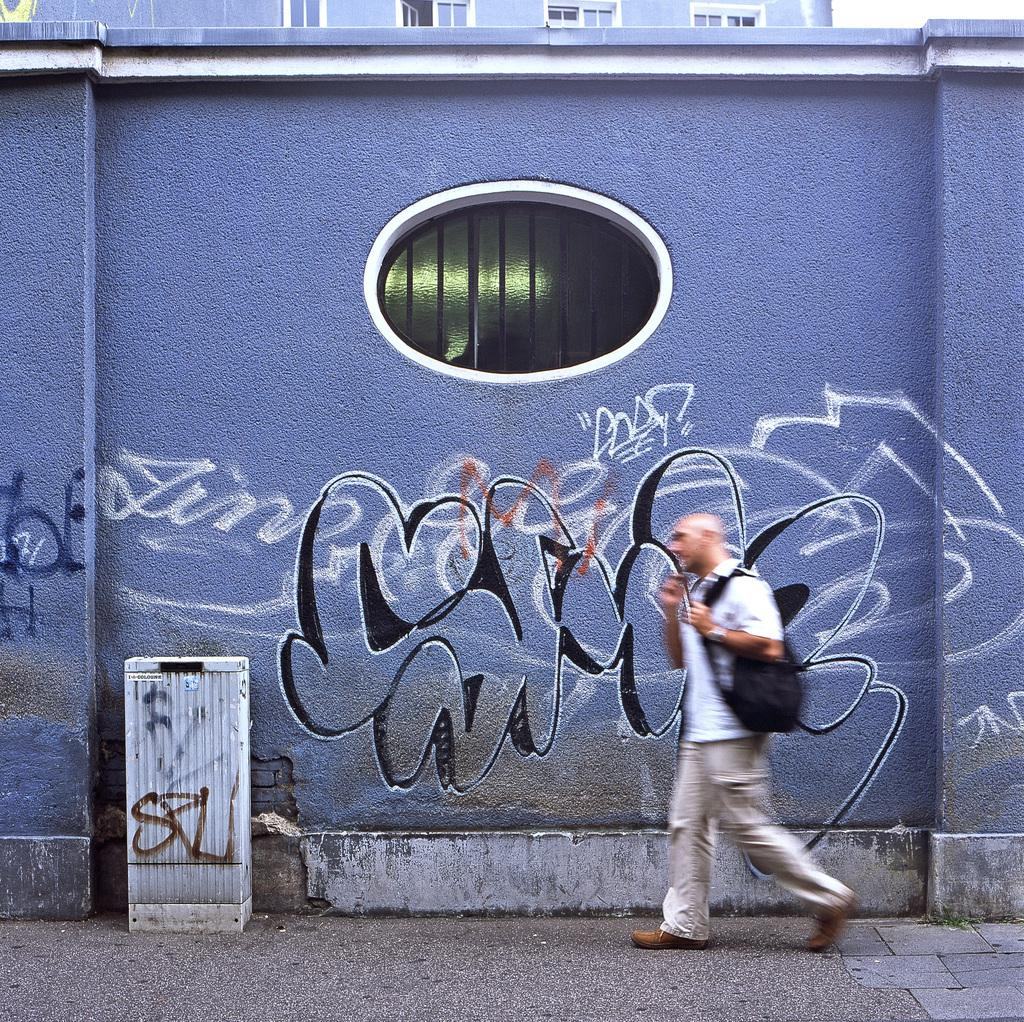Who is present in the image? There is a person in the image. What is the person carrying on their back? The person is wearing a backpack. What surface is the person walking on? The person is walking on the pavement. What type of furniture can be seen in the image? There is a table in the image. What is on the wall in the image? There is graffiti on the wall in the image. What type of structure is visible in the image? There is a building in the image. What architectural feature can be seen on the building? There are windows visible in the image. What brand of toothpaste is the person using in the image? There is no toothpaste present in the image, and the person's activities are not related to toothpaste. 